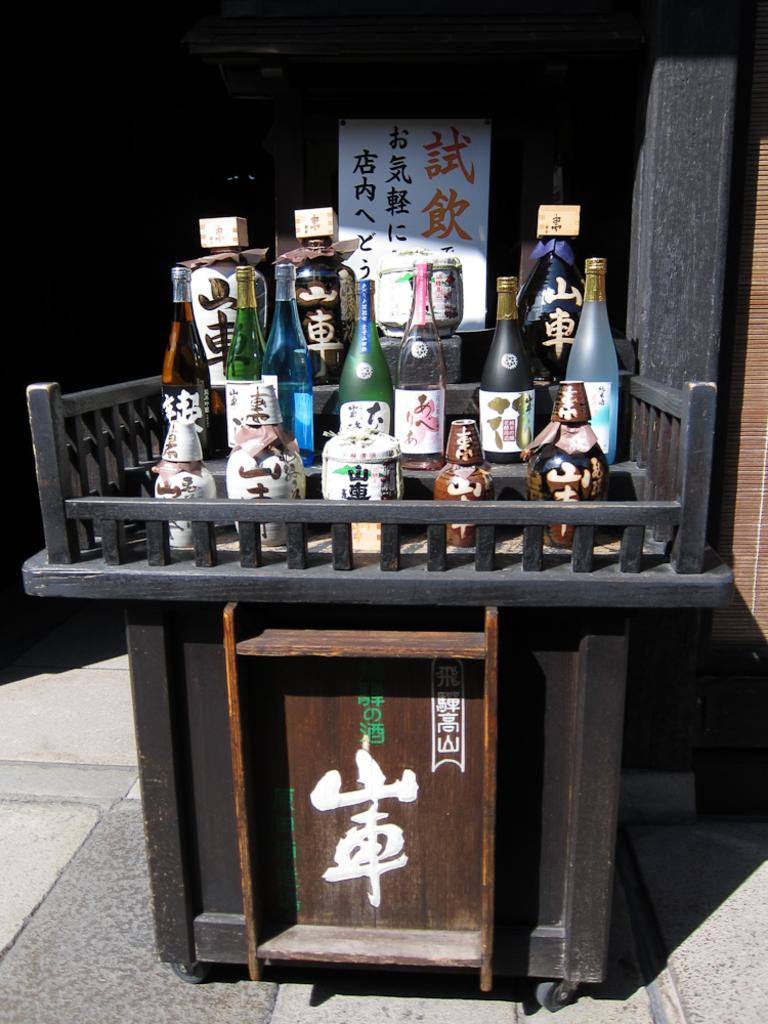What type of bottles are visible in the image? There are wine bottles in the image. What piece of furniture is present in the image? There is a table in the image. What type of polish is being applied to the territory in the image? There is no polish or territory present in the image; it only features wine bottles and a table. 